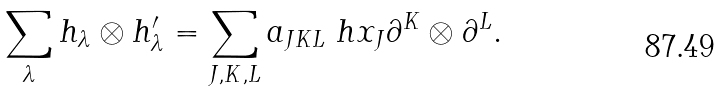Convert formula to latex. <formula><loc_0><loc_0><loc_500><loc_500>\sum _ { \lambda } h _ { \lambda } \otimes h ^ { \prime } _ { \lambda } = \sum _ { J , K , L } a _ { J K L } \ h x _ { J } \partial ^ { K } \otimes \partial ^ { L } .</formula> 